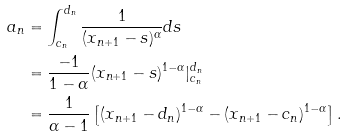Convert formula to latex. <formula><loc_0><loc_0><loc_500><loc_500>a _ { n } & = \int _ { c _ { n } } ^ { d _ { n } } \frac { 1 } { ( x _ { n + 1 } - s ) ^ { \alpha } } d s \\ & = \frac { - 1 } { 1 - \alpha } ( x _ { n + 1 } - s ) ^ { 1 - \alpha } | ^ { d _ { n } } _ { c _ { n } } \\ & = \frac { 1 } { \alpha - 1 } \left [ ( x _ { n + 1 } - d _ { n } ) ^ { 1 - \alpha } - ( x _ { n + 1 } - c _ { n } ) ^ { 1 - \alpha } \right ] .</formula> 